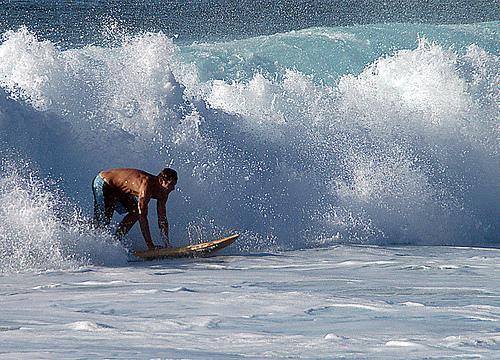How many surfers are in the scene?
Give a very brief answer. 1. 